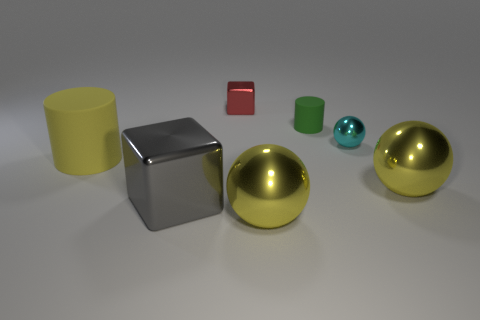There is a yellow sphere to the left of the matte cylinder right of the metallic block behind the large yellow matte cylinder; what is it made of? The yellow sphere you're referring to appears to be made of a material with a metallic sheen, suggesting that it could be a metal like the silver block nearby. However, without additional context or tactile information, we can't determine the exact material composition. 